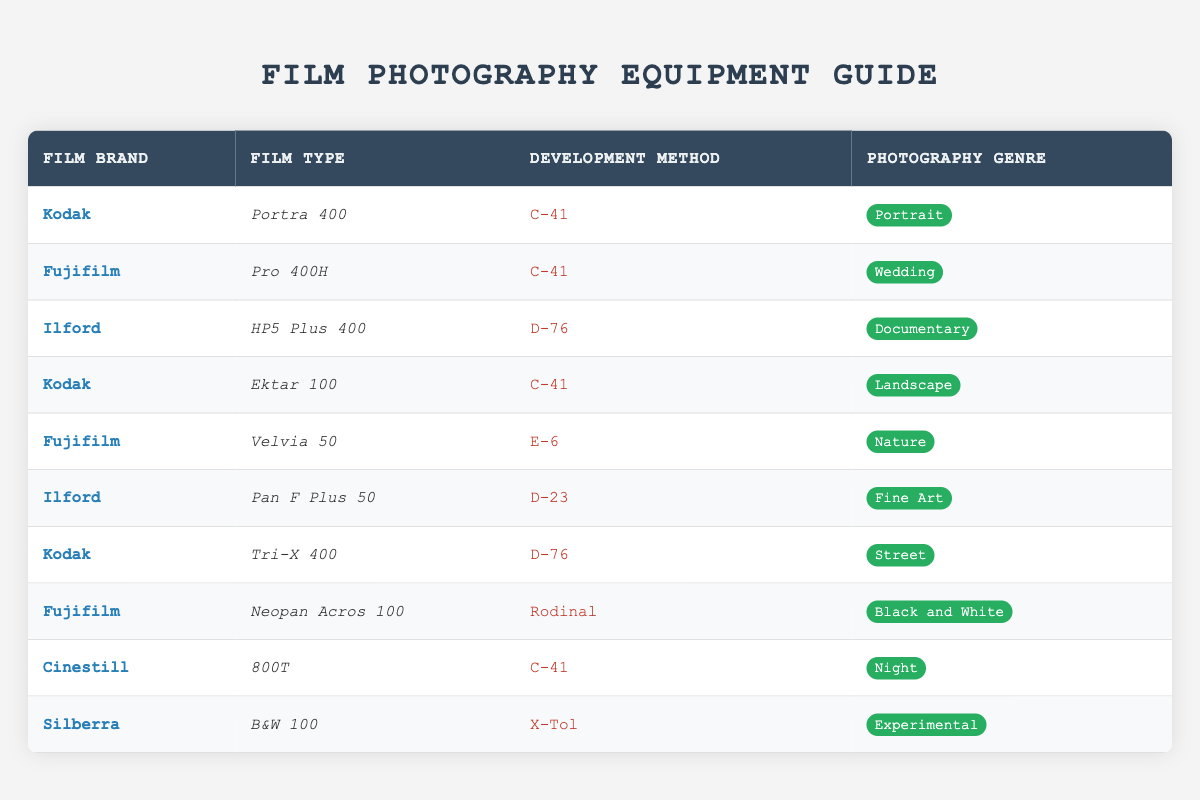What film types use the C-41 development method? The table lists three film types that use the C-41 development method: Portra 400 by Kodak, Pro 400H by Fujifilm, Ektar 100 by Kodak, and 800T by Cinestill.
Answer: Portra 400, Pro 400H, Ektar 100, 800T Which photography genre is associated with Ilford's HP5 Plus 400? Looking at the table, HP5 Plus 400 is associated with the Documentary genre as specified.
Answer: Documentary What is the development method for Fujifilm's Velvia 50? According to the table, Velvia 50 utilizes the E-6 development method.
Answer: E-6 Are there any films with the development method D-76 used in Fine Art photography? Referring to the table, there are no films with the D-76 development method listed for Fine Art photography. The only D-76 films are HP5 Plus 400 (Documentary) and Tri-X 400 (Street).
Answer: No How many film brands use the C-41 development method? The table shows that four brands (Kodak, Fujifilm, Cinestill) use the C-41 method with five film types (Portra 400, Pro 400H, Ektar 100, 800T). Thus, the answer is 3 brands.
Answer: 3 What is the photography genre of Silberra's B&W 100? From the table, B&W 100 is categorized under the Experimental genre.
Answer: Experimental Which film has the highest ISO rating and what is its photography genre? Scanning through the table, the film with the highest ISO rating is HP5 Plus 400 by Ilford, which falls under the Documentary genre.
Answer: HP5 Plus 400, Documentary What method do street photographers prefer based on the film data? The table indicates that street photographers prefer Kodak's Tri-X 400, which is developed using the D-76 method.
Answer: D-76 Can you find any films suitable for Night photography? Yes, the table lists Cinestill's 800T, which is specifically designated for Night photography.
Answer: Yes 